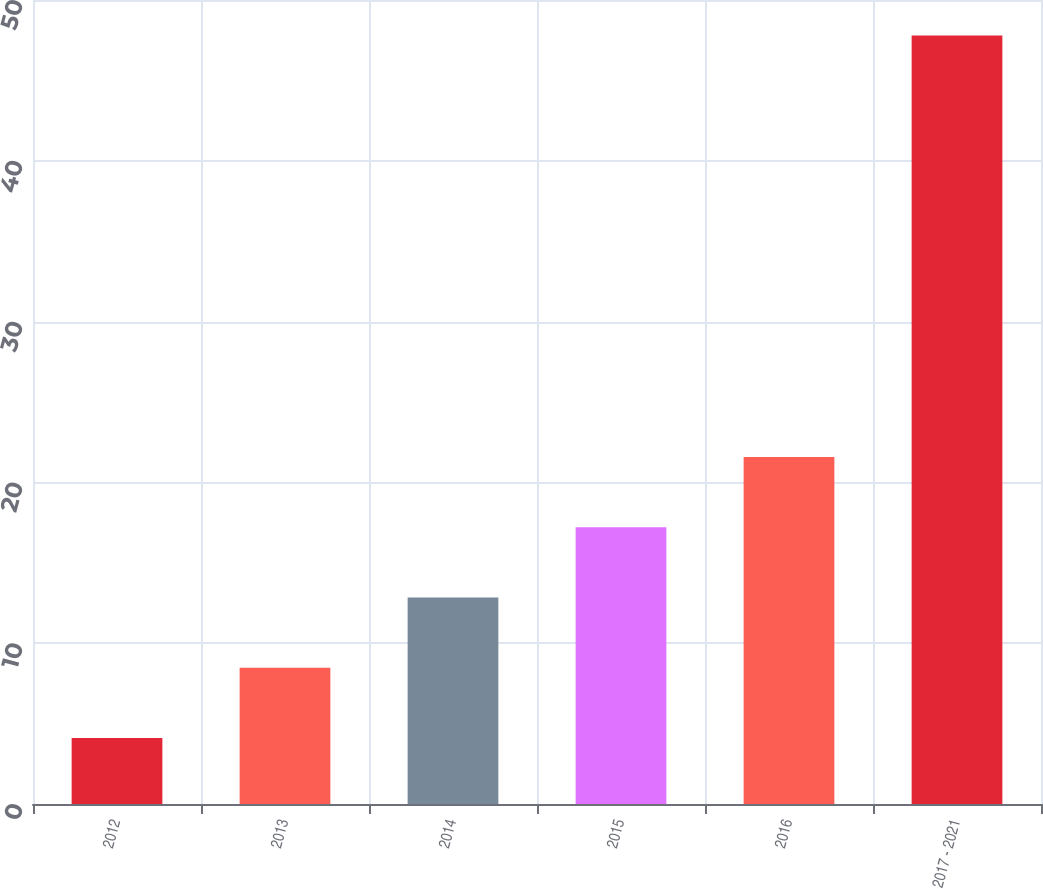<chart> <loc_0><loc_0><loc_500><loc_500><bar_chart><fcel>2012<fcel>2013<fcel>2014<fcel>2015<fcel>2016<fcel>2017 - 2021<nl><fcel>4.1<fcel>8.47<fcel>12.84<fcel>17.21<fcel>21.58<fcel>47.8<nl></chart> 